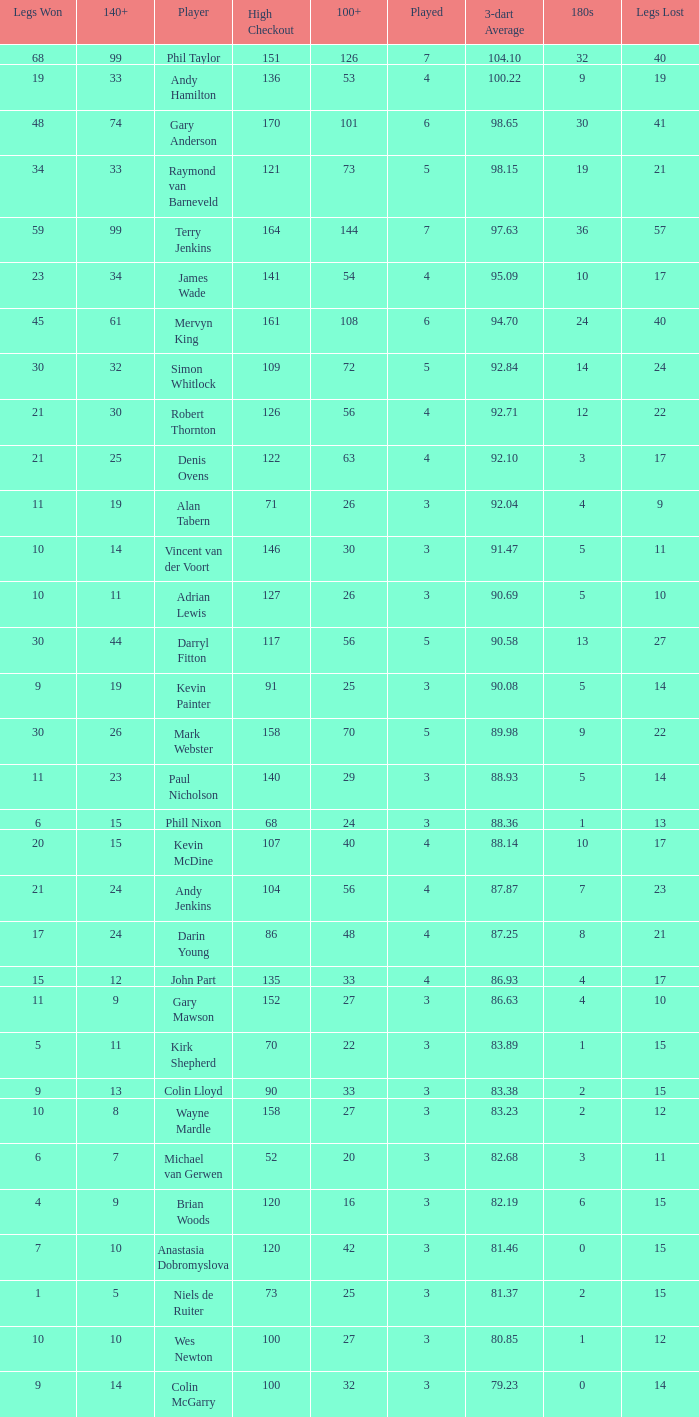What is the total number of 3-dart average when legs lost is larger than 41, and played is larger than 7? 0.0. 